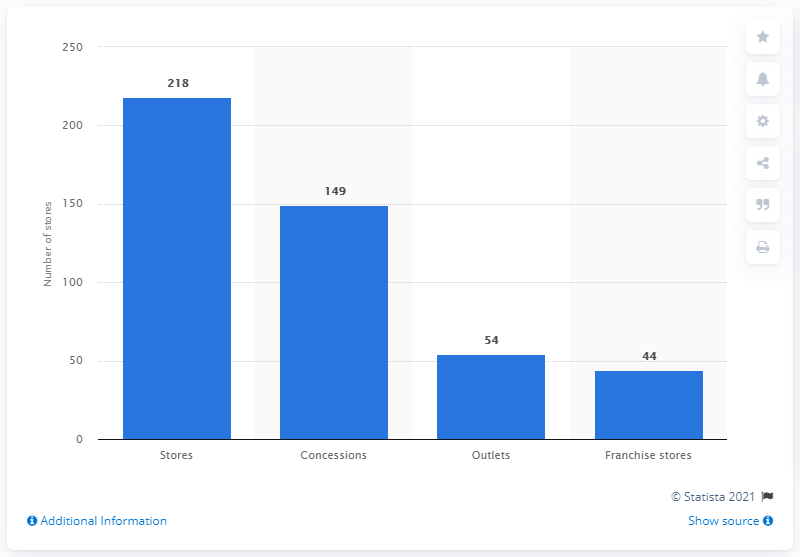Identify some key points in this picture. As of 2020, Burberry operated a total of 218 stores worldwide. 